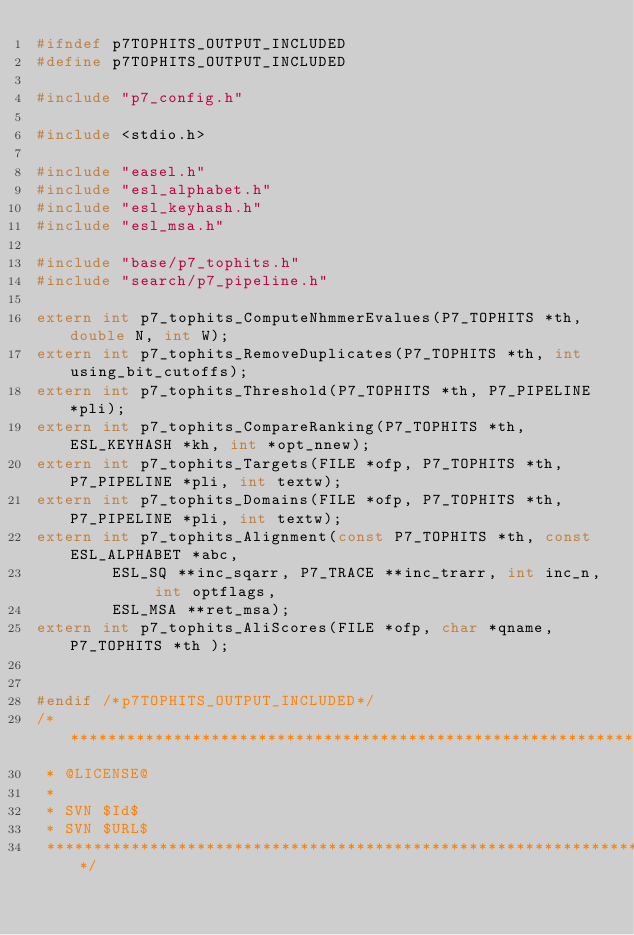Convert code to text. <code><loc_0><loc_0><loc_500><loc_500><_C_>#ifndef p7TOPHITS_OUTPUT_INCLUDED
#define p7TOPHITS_OUTPUT_INCLUDED

#include "p7_config.h"

#include <stdio.h>

#include "easel.h"
#include "esl_alphabet.h"
#include "esl_keyhash.h"
#include "esl_msa.h"

#include "base/p7_tophits.h"
#include "search/p7_pipeline.h"

extern int p7_tophits_ComputeNhmmerEvalues(P7_TOPHITS *th, double N, int W);
extern int p7_tophits_RemoveDuplicates(P7_TOPHITS *th, int using_bit_cutoffs);
extern int p7_tophits_Threshold(P7_TOPHITS *th, P7_PIPELINE *pli);
extern int p7_tophits_CompareRanking(P7_TOPHITS *th, ESL_KEYHASH *kh, int *opt_nnew);
extern int p7_tophits_Targets(FILE *ofp, P7_TOPHITS *th, P7_PIPELINE *pli, int textw);
extern int p7_tophits_Domains(FILE *ofp, P7_TOPHITS *th, P7_PIPELINE *pli, int textw);
extern int p7_tophits_Alignment(const P7_TOPHITS *th, const ESL_ALPHABET *abc, 
				ESL_SQ **inc_sqarr, P7_TRACE **inc_trarr, int inc_n, int optflags,
				ESL_MSA **ret_msa);
extern int p7_tophits_AliScores(FILE *ofp, char *qname, P7_TOPHITS *th );


#endif /*p7TOPHITS_OUTPUT_INCLUDED*/
/*****************************************************************
 * @LICENSE@
 * 
 * SVN $Id$
 * SVN $URL$
 *****************************************************************/
</code> 